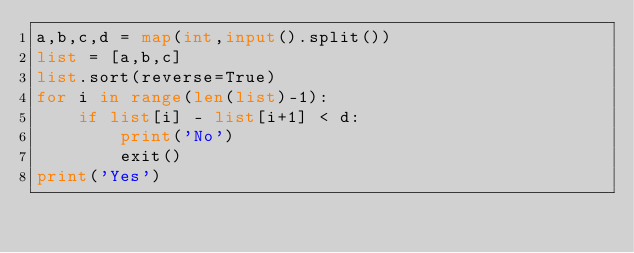Convert code to text. <code><loc_0><loc_0><loc_500><loc_500><_Python_>a,b,c,d = map(int,input().split())
list = [a,b,c]
list.sort(reverse=True)
for i in range(len(list)-1):
    if list[i] - list[i+1] < d:
        print('No')
        exit()
print('Yes')</code> 